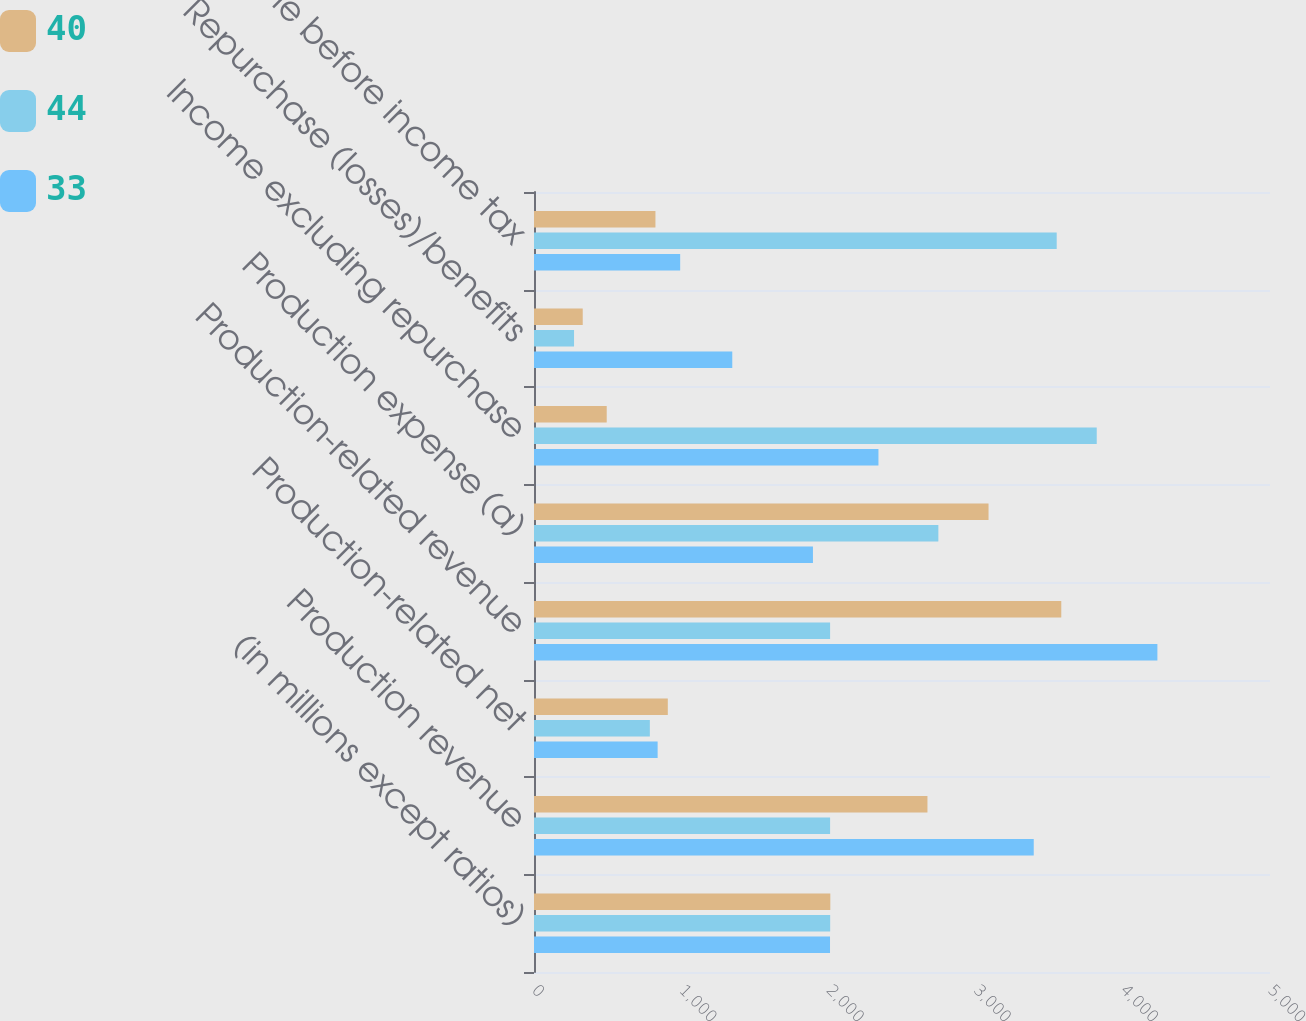Convert chart to OTSL. <chart><loc_0><loc_0><loc_500><loc_500><stacked_bar_chart><ecel><fcel>(in millions except ratios)<fcel>Production revenue<fcel>Production-related net<fcel>Production-related revenue<fcel>Production expense (a)<fcel>Income excluding repurchase<fcel>Repurchase (losses)/benefits<fcel>Income before income tax<nl><fcel>40<fcel>2013<fcel>2673<fcel>909<fcel>3582<fcel>3088<fcel>494<fcel>331<fcel>825<nl><fcel>44<fcel>2012<fcel>2011.5<fcel>787<fcel>2011.5<fcel>2747<fcel>3823<fcel>272<fcel>3551<nl><fcel>33<fcel>2011<fcel>3395<fcel>840<fcel>4235<fcel>1895<fcel>2340<fcel>1347<fcel>993<nl></chart> 